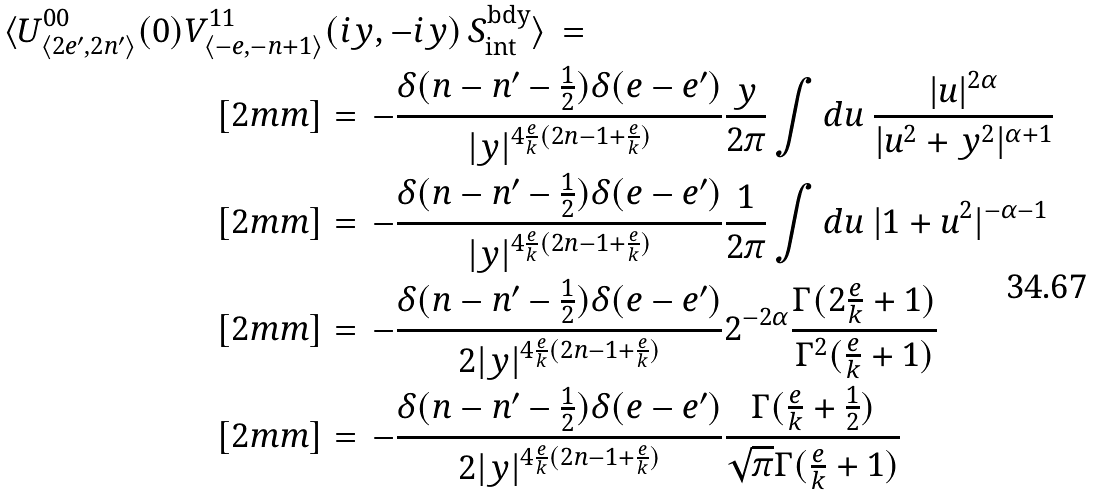Convert formula to latex. <formula><loc_0><loc_0><loc_500><loc_500>\langle U ^ { 0 0 } _ { \langle 2 e ^ { \prime } , 2 n ^ { \prime } \rangle } ( 0 ) V ^ { 1 1 } _ { \langle - e , - n + 1 \rangle } & ( i y , - i y ) \, S ^ { \text {bdy} } _ { \text {int} } \rangle \, = \, \\ [ 2 m m ] & = \, - \frac { \delta ( n - n ^ { \prime } - \frac { 1 } { 2 } ) \delta ( e - e ^ { \prime } ) } { | y | ^ { 4 \frac { e } { k } ( 2 n - 1 + \frac { e } { k } ) } } \frac { y } { 2 \pi } \int d u \ \frac { | u | ^ { 2 \alpha } } { | u ^ { 2 } + y ^ { 2 } | ^ { \alpha + 1 } } \\ [ 2 m m ] & = \, - \frac { \delta ( n - n ^ { \prime } - \frac { 1 } { 2 } ) \delta ( e - e ^ { \prime } ) } { | y | ^ { 4 \frac { e } { k } ( 2 n - 1 + \frac { e } { k } ) } } \frac { 1 } { 2 \pi } \int d u \ | 1 + u ^ { 2 } | ^ { - \alpha - 1 } \\ [ 2 m m ] & = \, - \frac { \delta ( n - n ^ { \prime } - \frac { 1 } { 2 } ) \delta ( e - e ^ { \prime } ) } { 2 | y | ^ { 4 \frac { e } { k } ( 2 n - 1 + \frac { e } { k } ) } } 2 ^ { - 2 \alpha } \frac { \Gamma ( 2 \frac { e } { k } + 1 ) } { \Gamma ^ { 2 } ( \frac { e } { k } + 1 ) } \\ [ 2 m m ] & = \, - \frac { \delta ( n - n ^ { \prime } - \frac { 1 } { 2 } ) \delta ( e - e ^ { \prime } ) } { 2 | y | ^ { 4 \frac { e } { k } ( 2 n - 1 + \frac { e } { k } ) } } \frac { \Gamma ( \frac { e } { k } + \frac { 1 } { 2 } ) } { \sqrt { \pi } \Gamma ( \frac { e } { k } + 1 ) }</formula> 